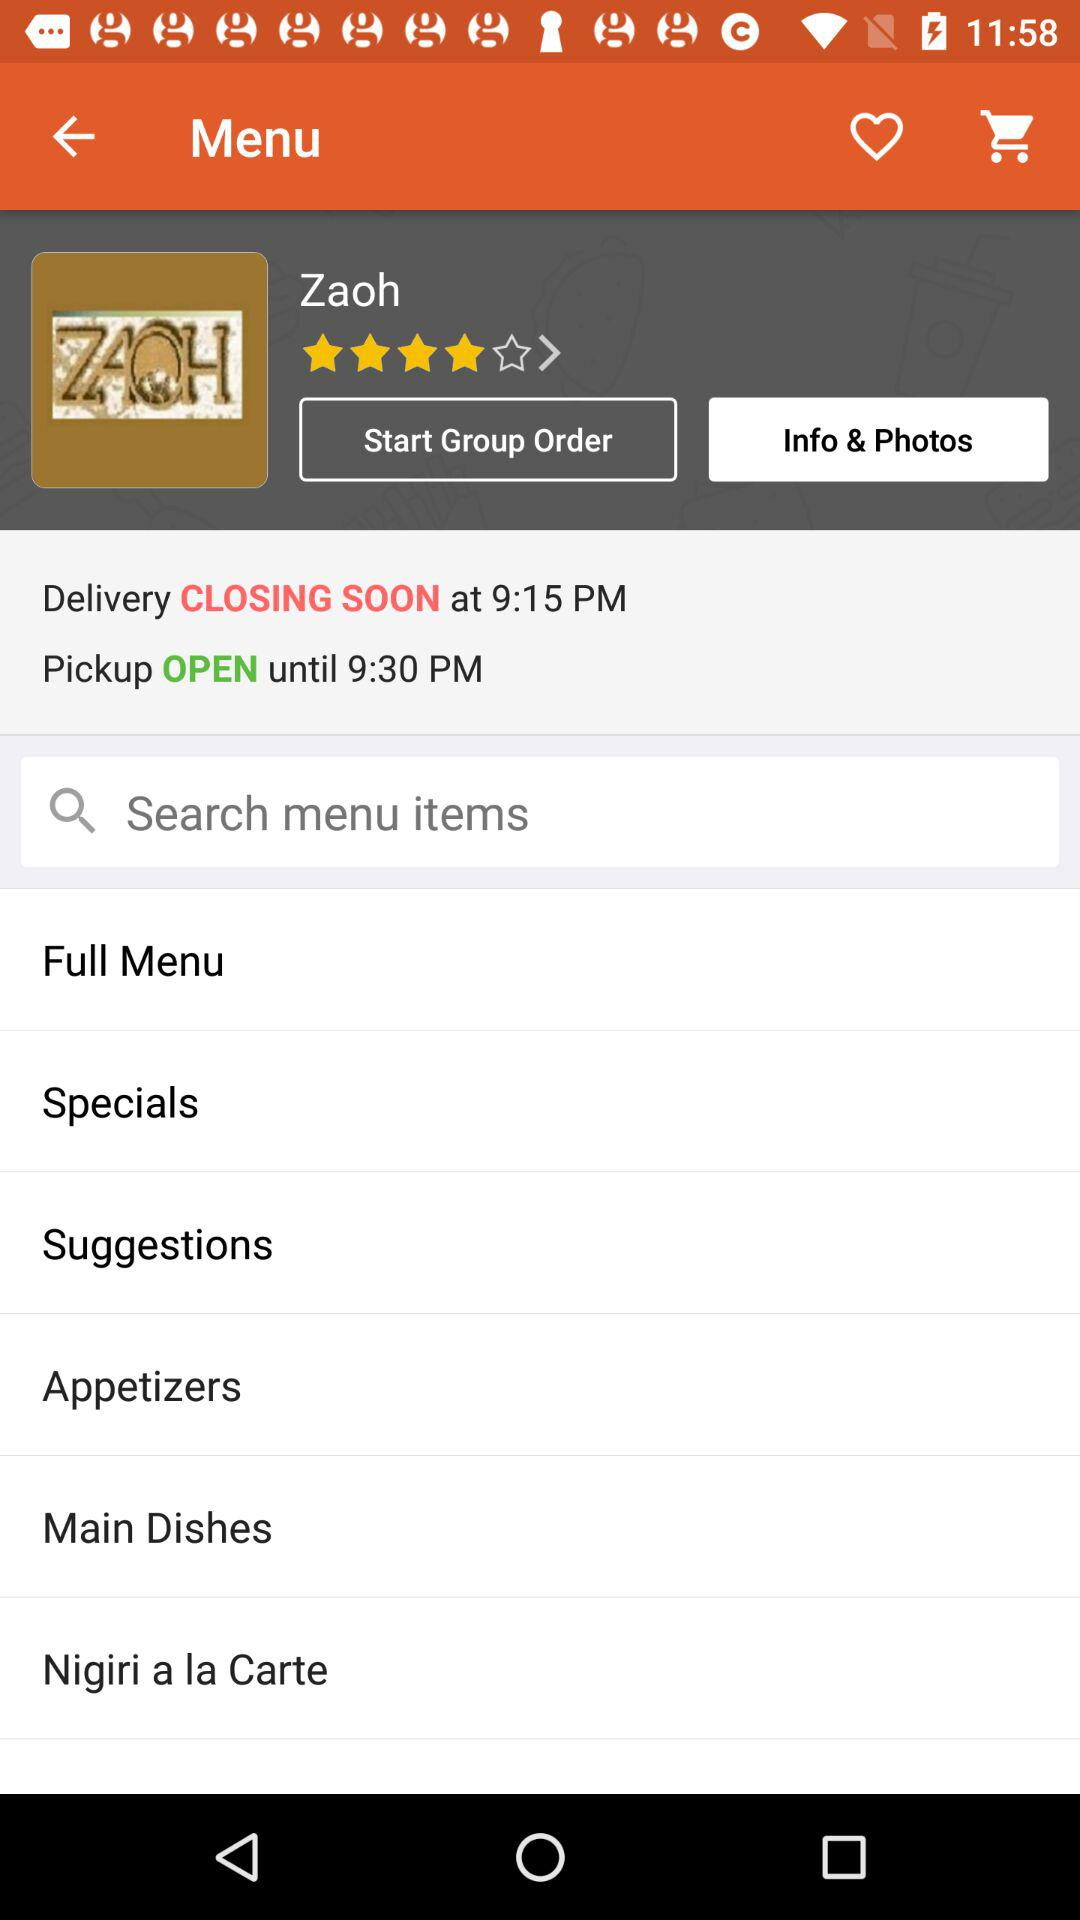What is the restaurant name? The restaurant name is Zaoh. 